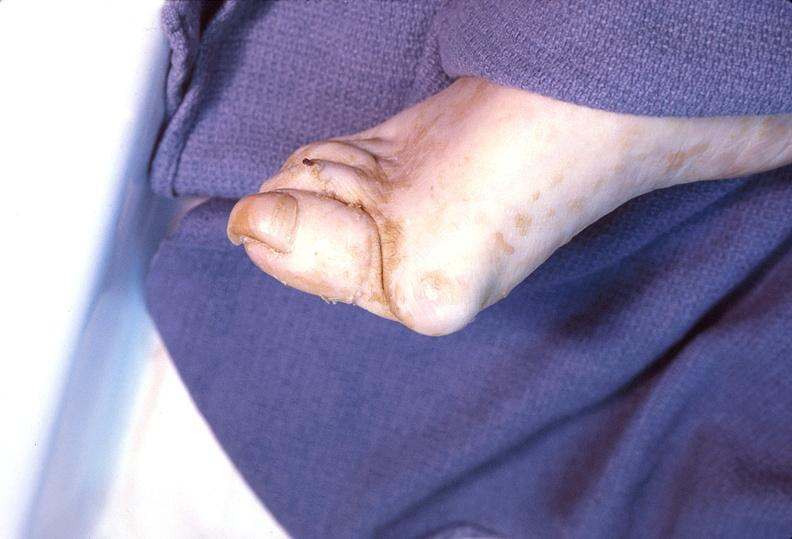what is present?
Answer the question using a single word or phrase. Musculoskeletal 